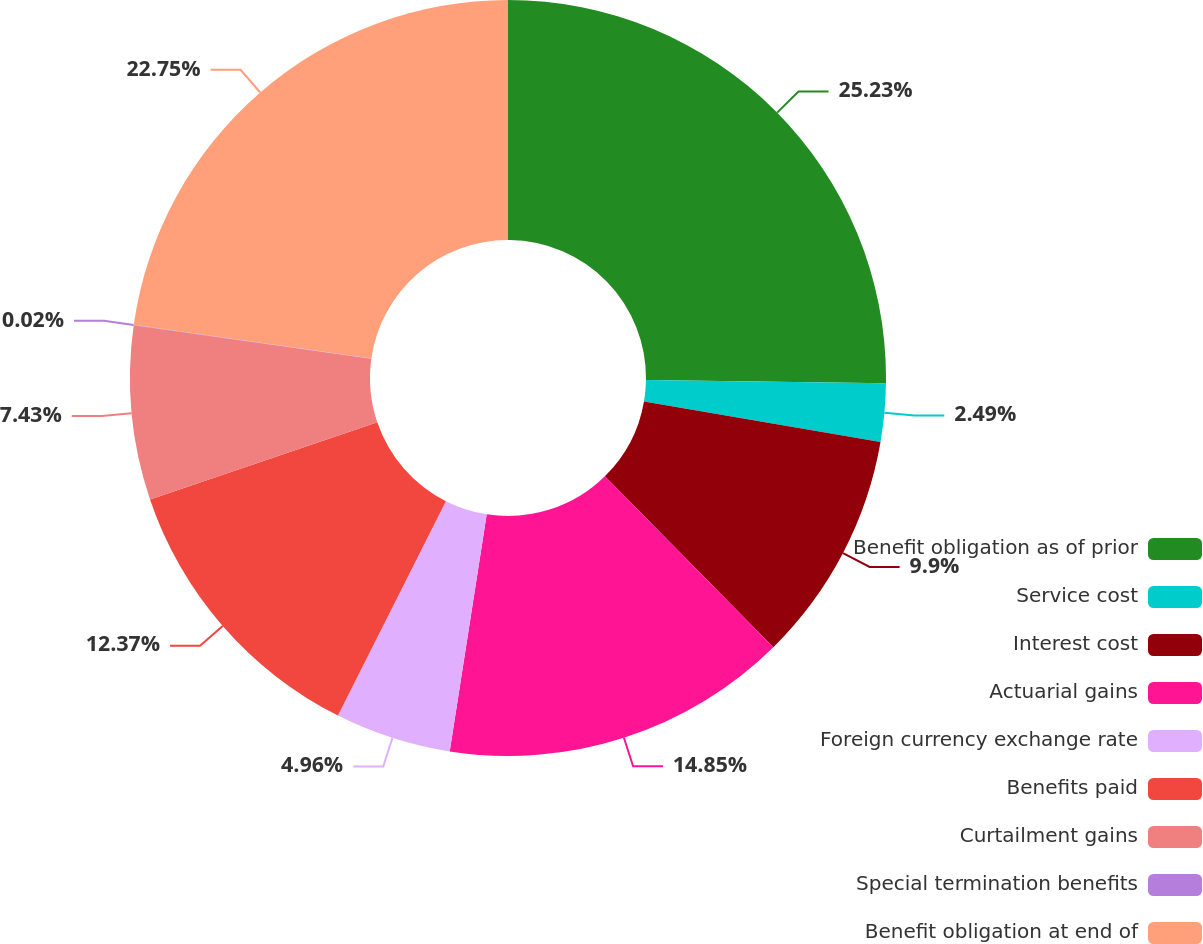Convert chart. <chart><loc_0><loc_0><loc_500><loc_500><pie_chart><fcel>Benefit obligation as of prior<fcel>Service cost<fcel>Interest cost<fcel>Actuarial gains<fcel>Foreign currency exchange rate<fcel>Benefits paid<fcel>Curtailment gains<fcel>Special termination benefits<fcel>Benefit obligation at end of<nl><fcel>25.22%<fcel>2.49%<fcel>9.9%<fcel>14.85%<fcel>4.96%<fcel>12.37%<fcel>7.43%<fcel>0.02%<fcel>22.75%<nl></chart> 